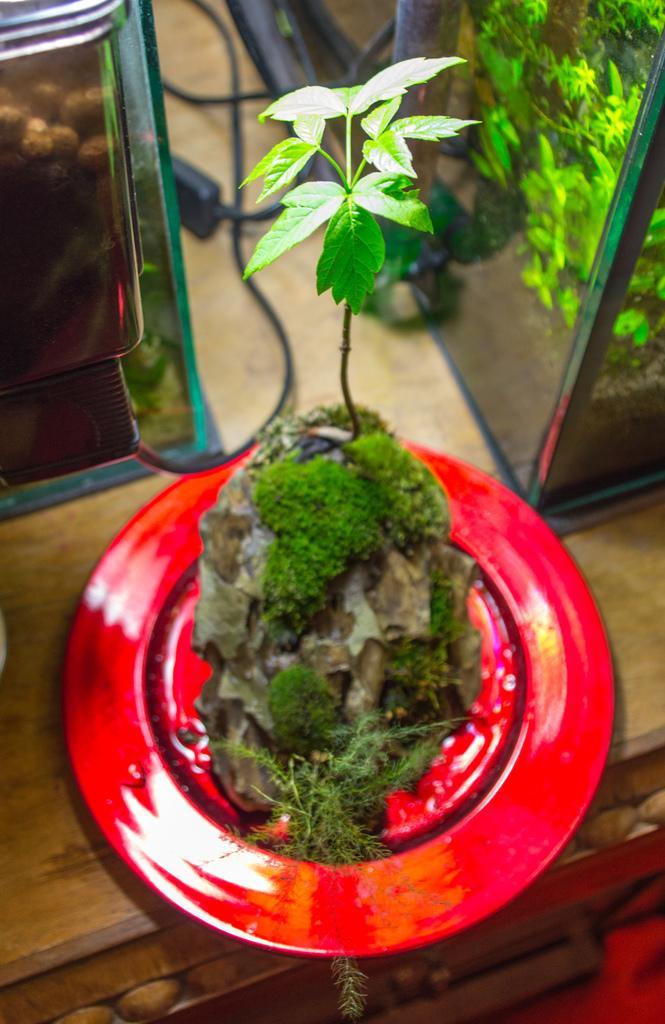How would you summarize this image in a sentence or two? In this picture in the center there is a plant and there's grass on the the pot which is in the center on the red colour object and in the background, on the right side there is an aquarium. In the aquarium there are planets visible. On the left side there are objects which are brown in colour and in the center there are wires and there is an adapter. 